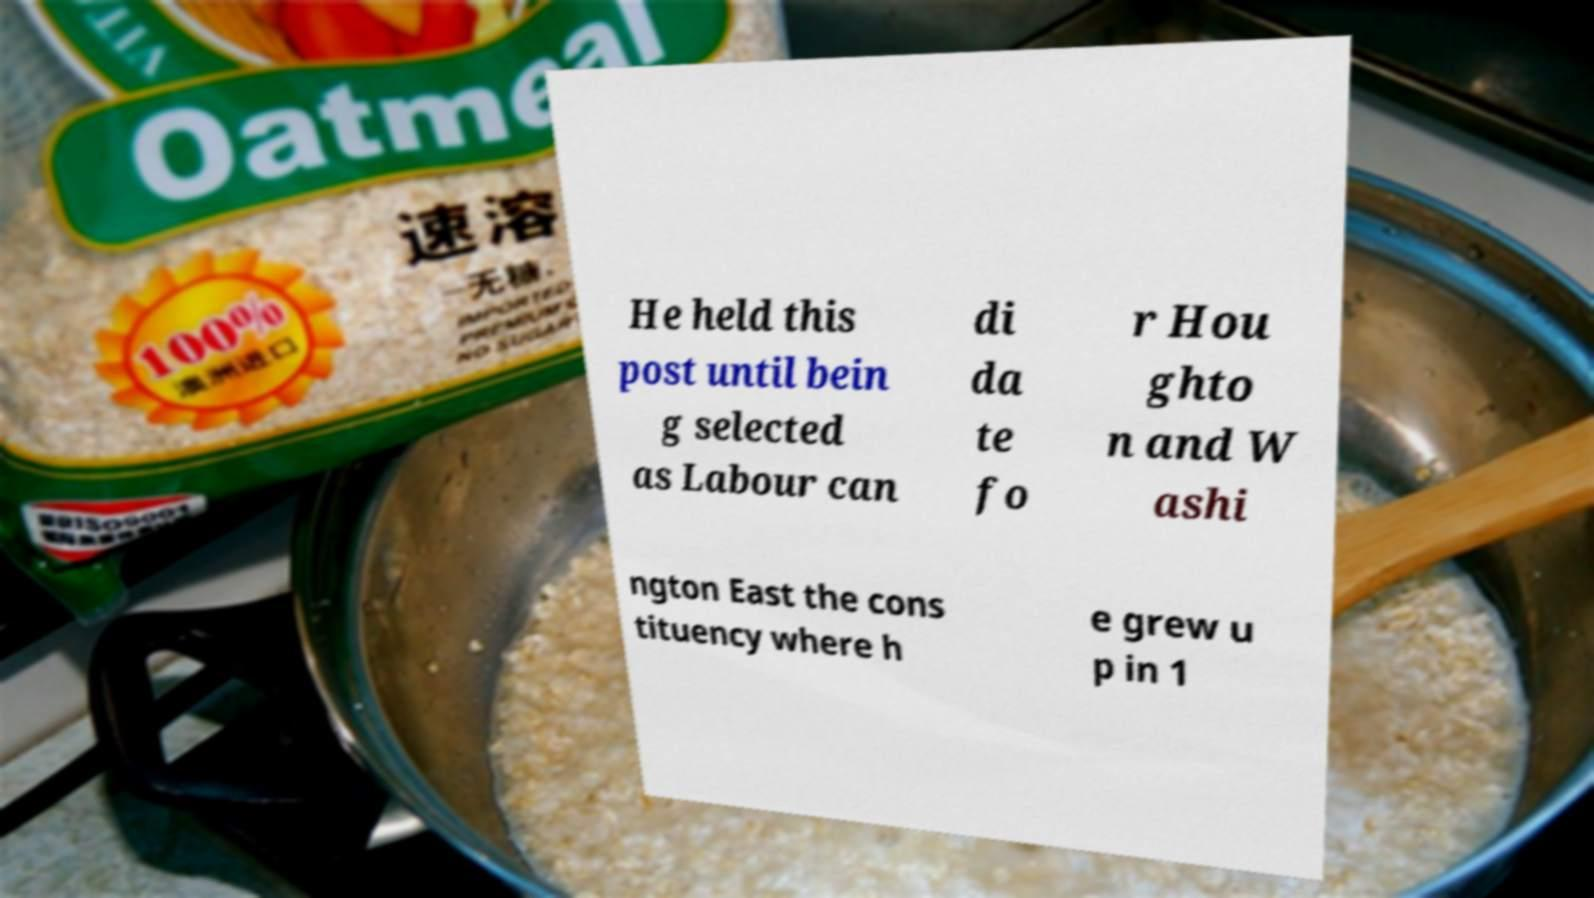Can you accurately transcribe the text from the provided image for me? He held this post until bein g selected as Labour can di da te fo r Hou ghto n and W ashi ngton East the cons tituency where h e grew u p in 1 